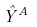<formula> <loc_0><loc_0><loc_500><loc_500>\hat { Y } ^ { A }</formula> 